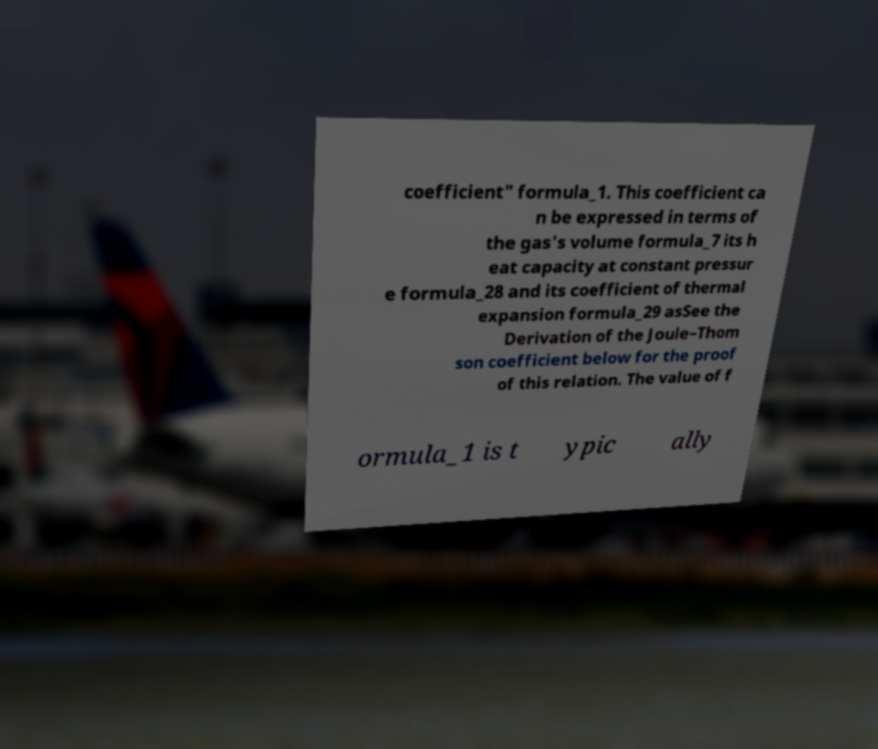Could you extract and type out the text from this image? coefficient" formula_1. This coefficient ca n be expressed in terms of the gas's volume formula_7 its h eat capacity at constant pressur e formula_28 and its coefficient of thermal expansion formula_29 asSee the Derivation of the Joule–Thom son coefficient below for the proof of this relation. The value of f ormula_1 is t ypic ally 